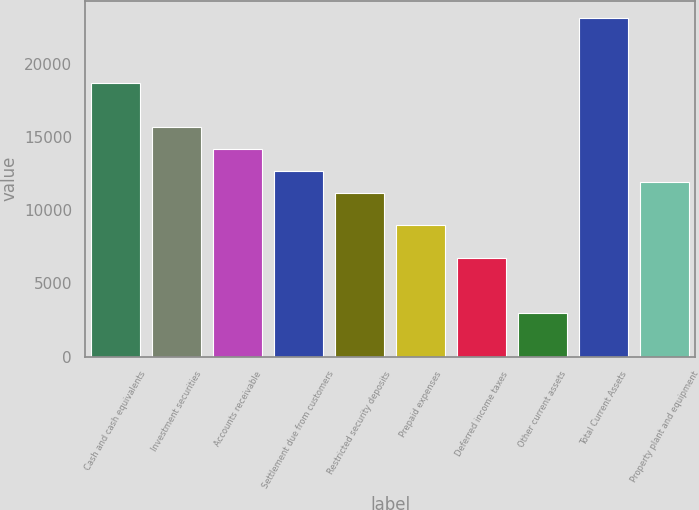<chart> <loc_0><loc_0><loc_500><loc_500><bar_chart><fcel>Cash and cash equivalents<fcel>Investment securities<fcel>Accounts receivable<fcel>Settlement due from customers<fcel>Restricted security deposits<fcel>Prepaid expenses<fcel>Deferred income taxes<fcel>Other current assets<fcel>Total Current Assets<fcel>Property plant and equipment<nl><fcel>18670.5<fcel>15683.7<fcel>14190.3<fcel>12696.9<fcel>11203.5<fcel>8963.4<fcel>6723.3<fcel>2989.8<fcel>23150.7<fcel>11950.2<nl></chart> 